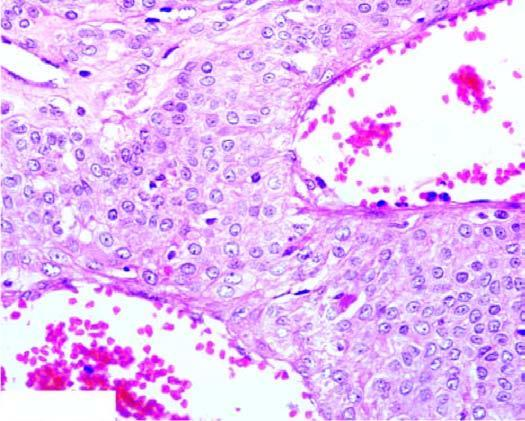re there blood-filled vascular channels lined by endothelial cells and surrounded by nests and masses of glomus cells?
Answer the question using a single word or phrase. Yes 